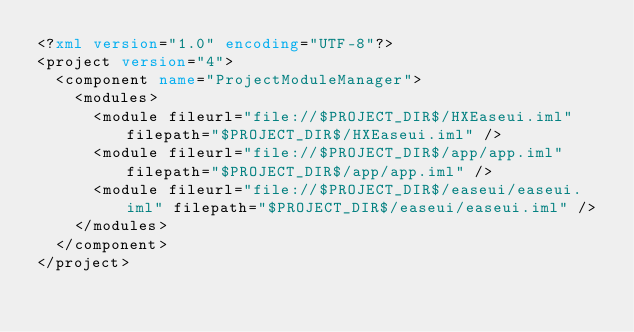<code> <loc_0><loc_0><loc_500><loc_500><_XML_><?xml version="1.0" encoding="UTF-8"?>
<project version="4">
  <component name="ProjectModuleManager">
    <modules>
      <module fileurl="file://$PROJECT_DIR$/HXEaseui.iml" filepath="$PROJECT_DIR$/HXEaseui.iml" />
      <module fileurl="file://$PROJECT_DIR$/app/app.iml" filepath="$PROJECT_DIR$/app/app.iml" />
      <module fileurl="file://$PROJECT_DIR$/easeui/easeui.iml" filepath="$PROJECT_DIR$/easeui/easeui.iml" />
    </modules>
  </component>
</project></code> 